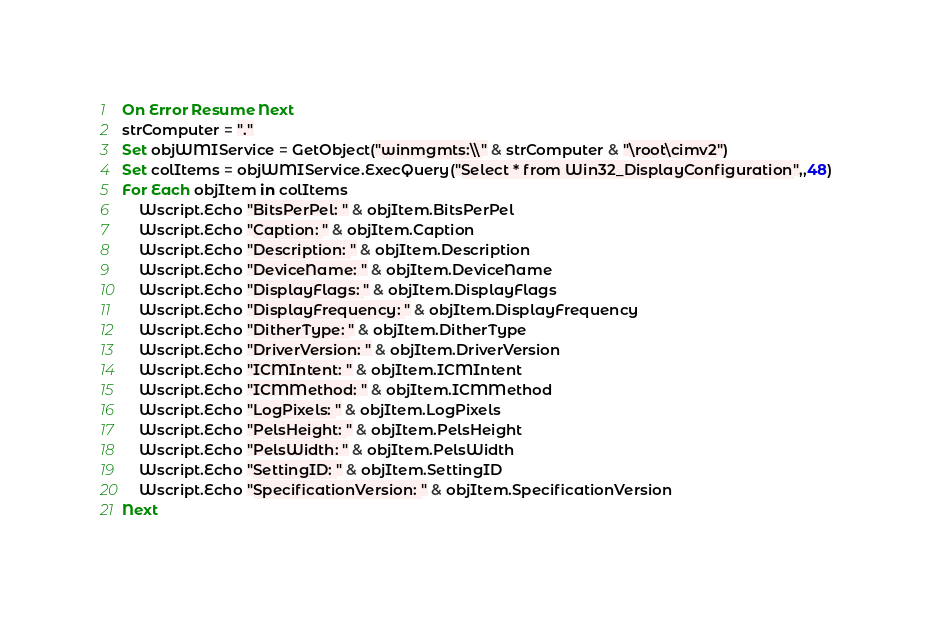Convert code to text. <code><loc_0><loc_0><loc_500><loc_500><_VisualBasic_>On Error Resume Next
strComputer = "."
Set objWMIService = GetObject("winmgmts:\\" & strComputer & "\root\cimv2")
Set colItems = objWMIService.ExecQuery("Select * from Win32_DisplayConfiguration",,48)
For Each objItem in colItems
    Wscript.Echo "BitsPerPel: " & objItem.BitsPerPel
    Wscript.Echo "Caption: " & objItem.Caption
    Wscript.Echo "Description: " & objItem.Description
    Wscript.Echo "DeviceName: " & objItem.DeviceName
    Wscript.Echo "DisplayFlags: " & objItem.DisplayFlags
    Wscript.Echo "DisplayFrequency: " & objItem.DisplayFrequency
    Wscript.Echo "DitherType: " & objItem.DitherType
    Wscript.Echo "DriverVersion: " & objItem.DriverVersion
    Wscript.Echo "ICMIntent: " & objItem.ICMIntent
    Wscript.Echo "ICMMethod: " & objItem.ICMMethod
    Wscript.Echo "LogPixels: " & objItem.LogPixels
    Wscript.Echo "PelsHeight: " & objItem.PelsHeight
    Wscript.Echo "PelsWidth: " & objItem.PelsWidth
    Wscript.Echo "SettingID: " & objItem.SettingID
    Wscript.Echo "SpecificationVersion: " & objItem.SpecificationVersion
Next

</code> 